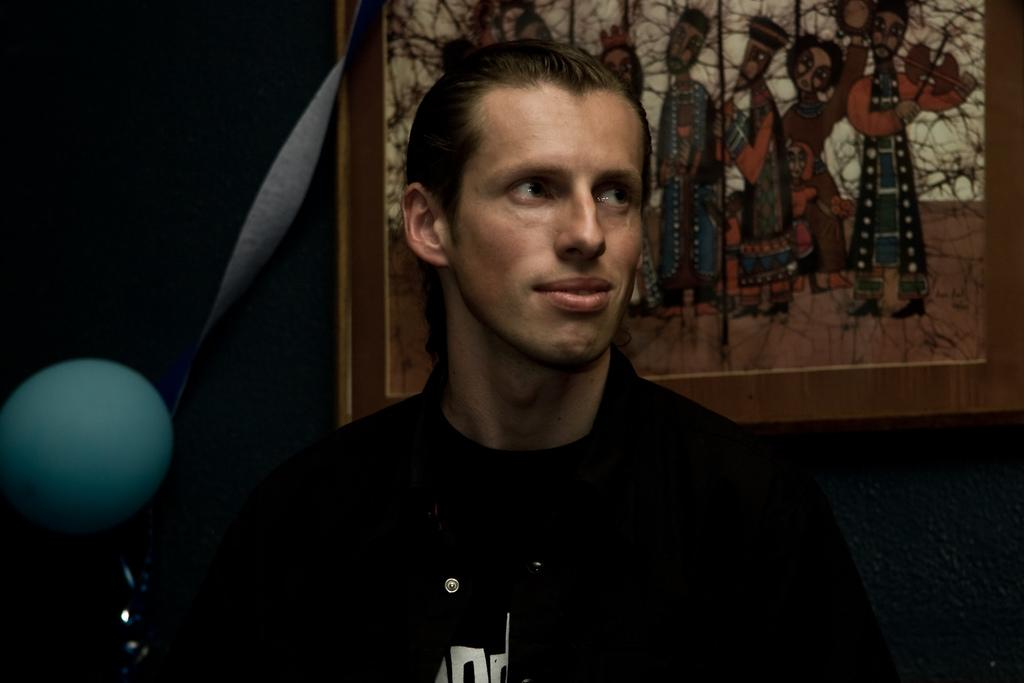Who is the main subject in the foreground of the picture? There is a man in the foreground of the picture. What can be seen on the wall behind the man? There is a photo frame on the wall behind the man. What color is the balloon in the image? There is a green balloon in the image. What effect does the man have on the planes in the image? There are no planes present in the image, so the man does not have any effect on them. 